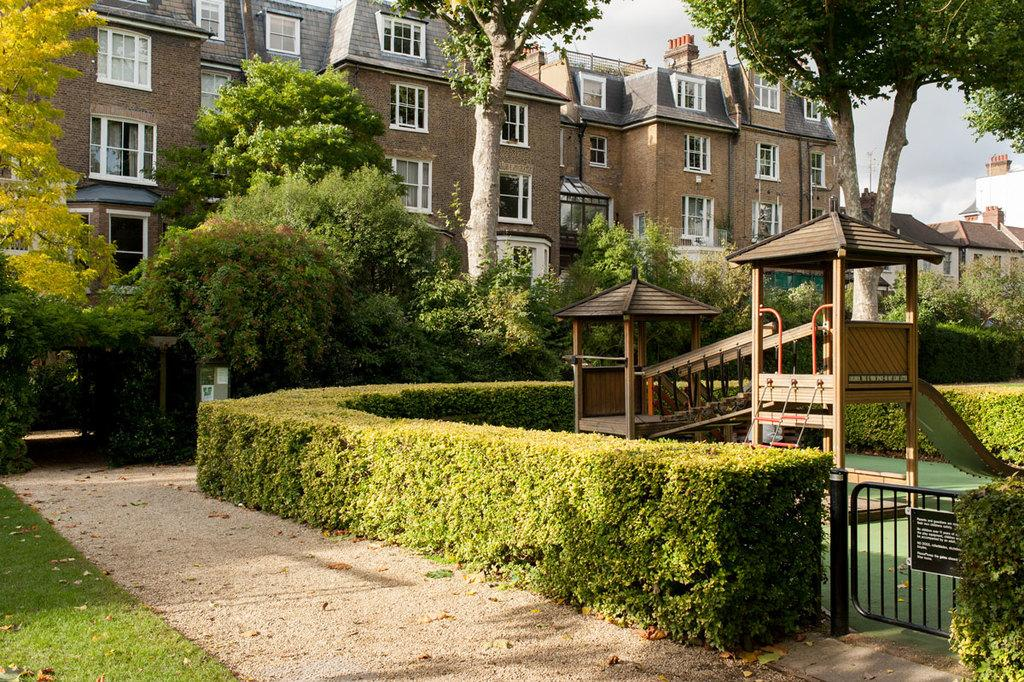What type of vegetation is present on the ground in the image? There is grass and plants on the ground in the image. What type of structures can be seen in the image? There are sheds in the image. What is the board used for in the image? The purpose of the board in the image is not specified, but it could be used for various purposes such as signage or display. What other objects are present in the image? There are objects in the image, but their specific nature is not mentioned in the facts. What can be seen in the background of the image? In the background of the image, there are buildings, trees, and the sky. Where is the nest located in the image? There is no nest present in the image. What type of canvas is used to cover the sheds in the image? There is no canvas mentioned or visible in the image. 